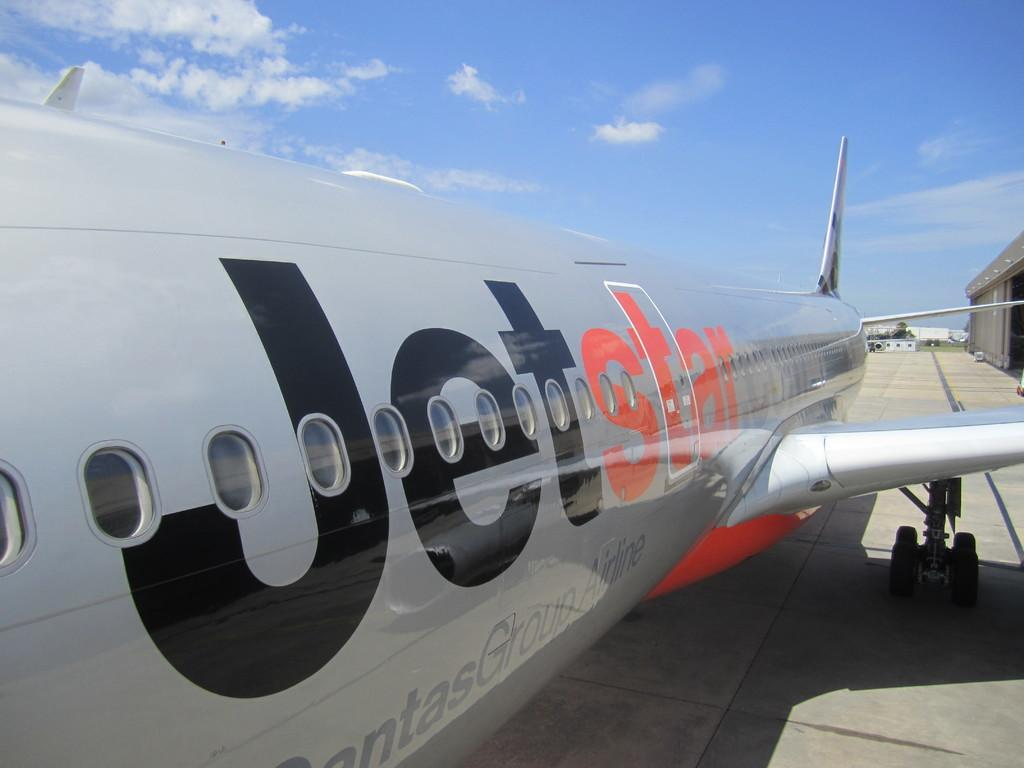Provide a one-sentence caption for the provided image. a silver jet with the letters Jet in black and star in red. 